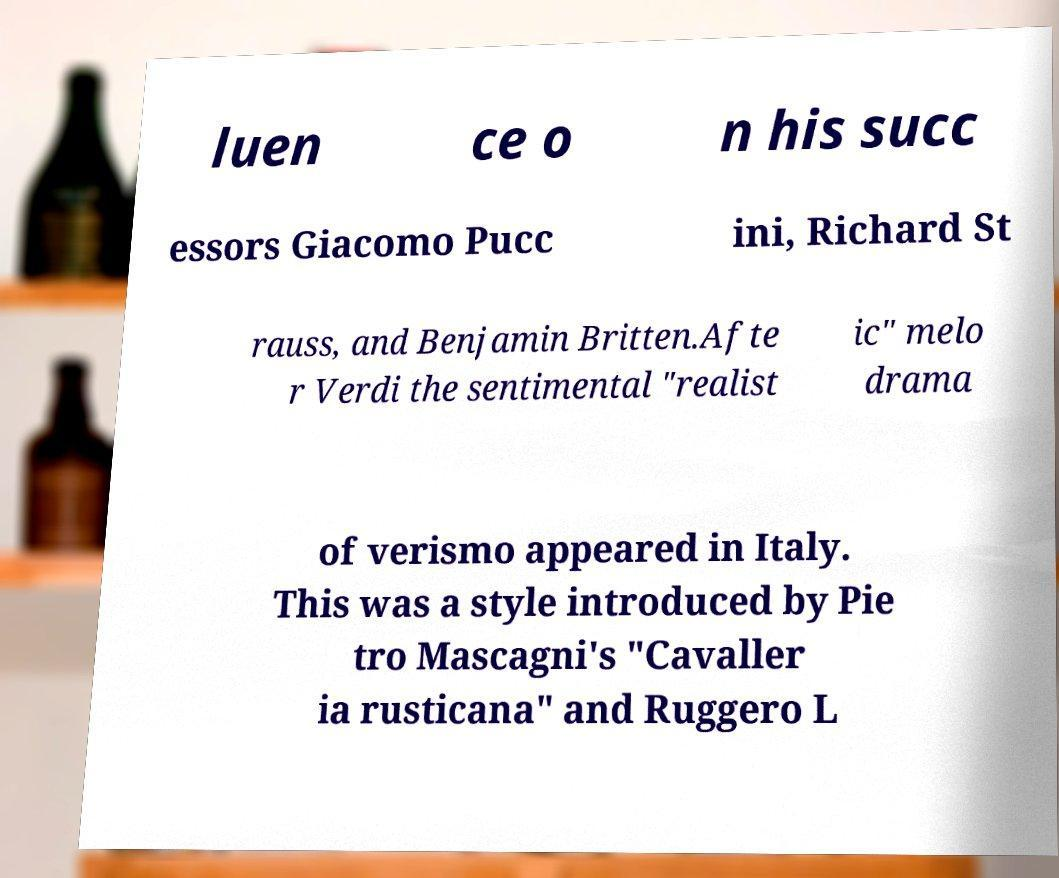Can you accurately transcribe the text from the provided image for me? luen ce o n his succ essors Giacomo Pucc ini, Richard St rauss, and Benjamin Britten.Afte r Verdi the sentimental "realist ic" melo drama of verismo appeared in Italy. This was a style introduced by Pie tro Mascagni's "Cavaller ia rusticana" and Ruggero L 